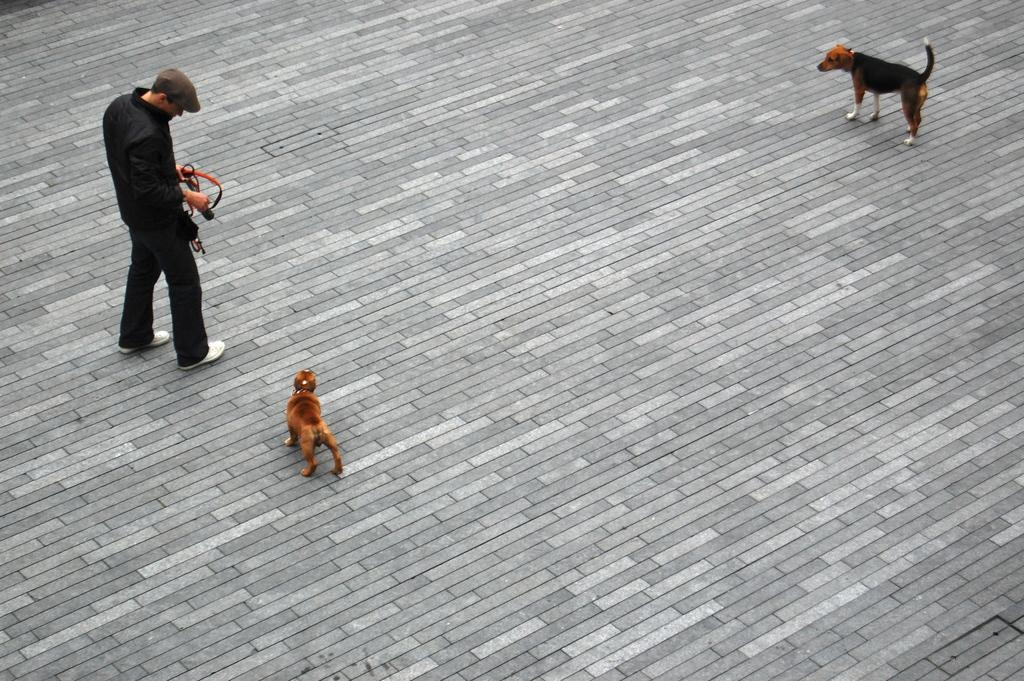What is the main subject of the image? There is a person in the image. What is the person doing in the image? The person is holding an object. Are there any animals present in the image? Yes, there are two dogs in front of the person. What type of breakfast is the person eating in the image? There is no indication of breakfast in the image; the person is holding an object. What industry does the person work in, as depicted in the image? The image does not provide any information about the person's occupation or industry. 